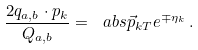Convert formula to latex. <formula><loc_0><loc_0><loc_500><loc_500>\frac { 2 q _ { a , b } \cdot p _ { k } } { Q _ { a , b } } = \ a b s { \vec { p } _ { k T } } e ^ { \mp \eta _ { k } } \, .</formula> 